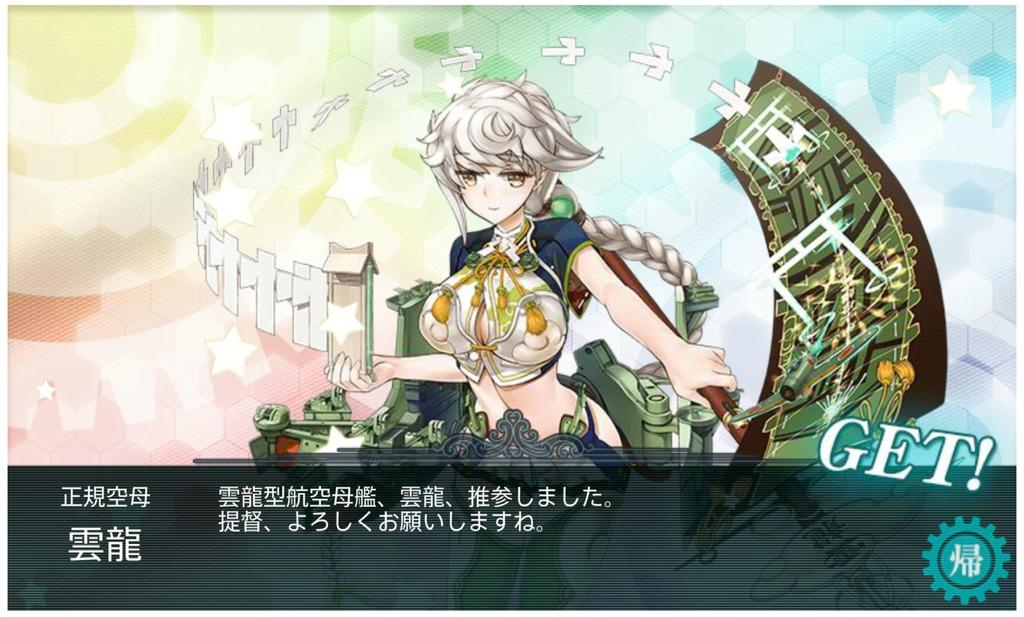What type of image is this? The image is animated. What is the girl in the image doing? The girl is holding objects in the image. Is there any text present in the image? Yes, there is text at the bottom of the image. Can you identify any branding or symbol in the image? Yes, there is a logo on the image. What is the weight of the plane visible in the image? There is no plane present in the image. How many stamps are on the girl's forehead in the image? There are no stamps on the girl's forehead in the image. 